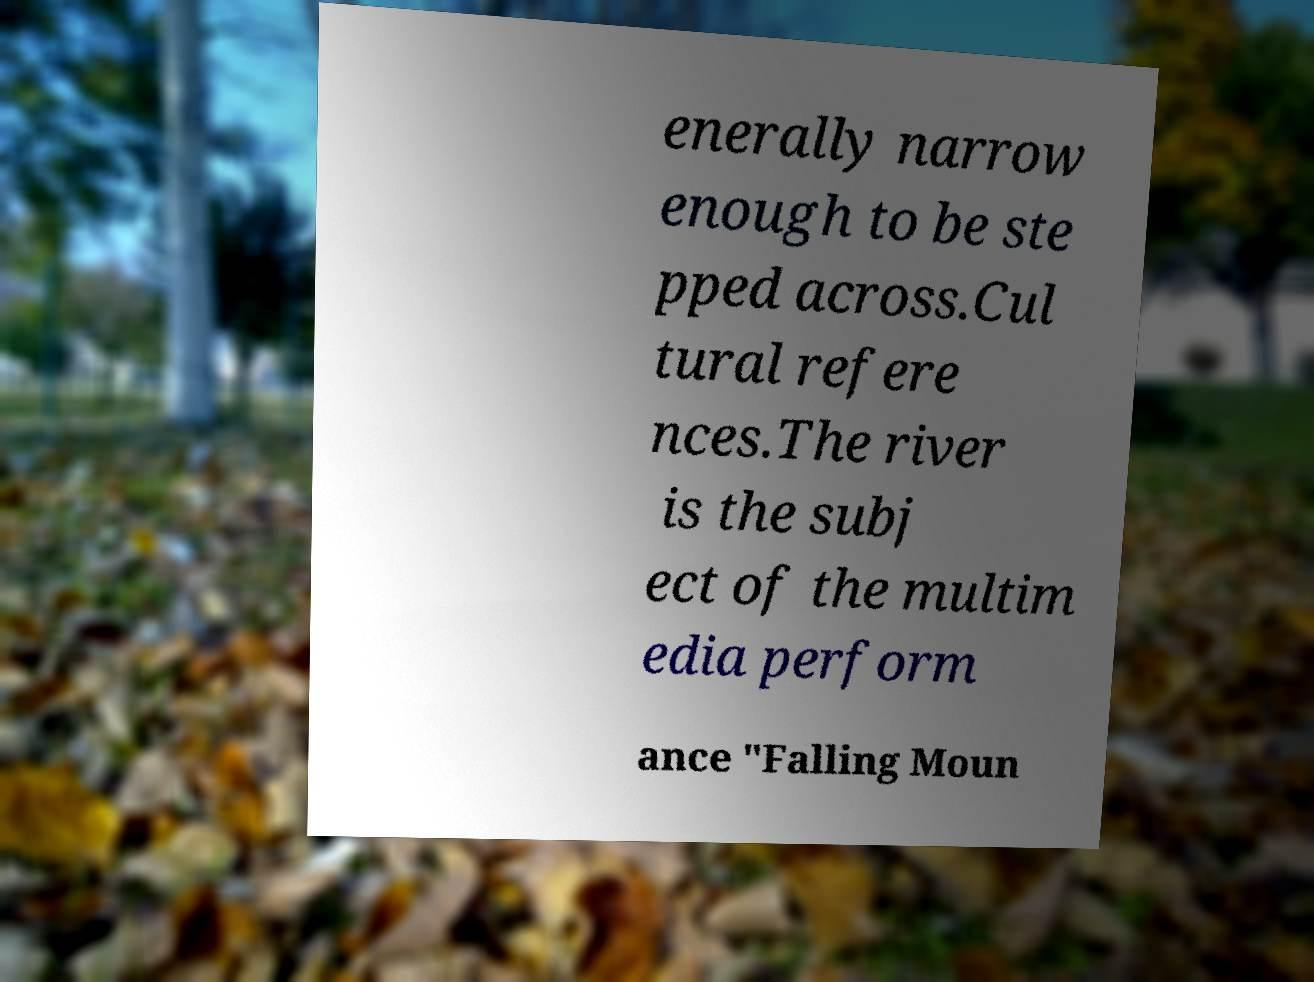What messages or text are displayed in this image? I need them in a readable, typed format. enerally narrow enough to be ste pped across.Cul tural refere nces.The river is the subj ect of the multim edia perform ance "Falling Moun 